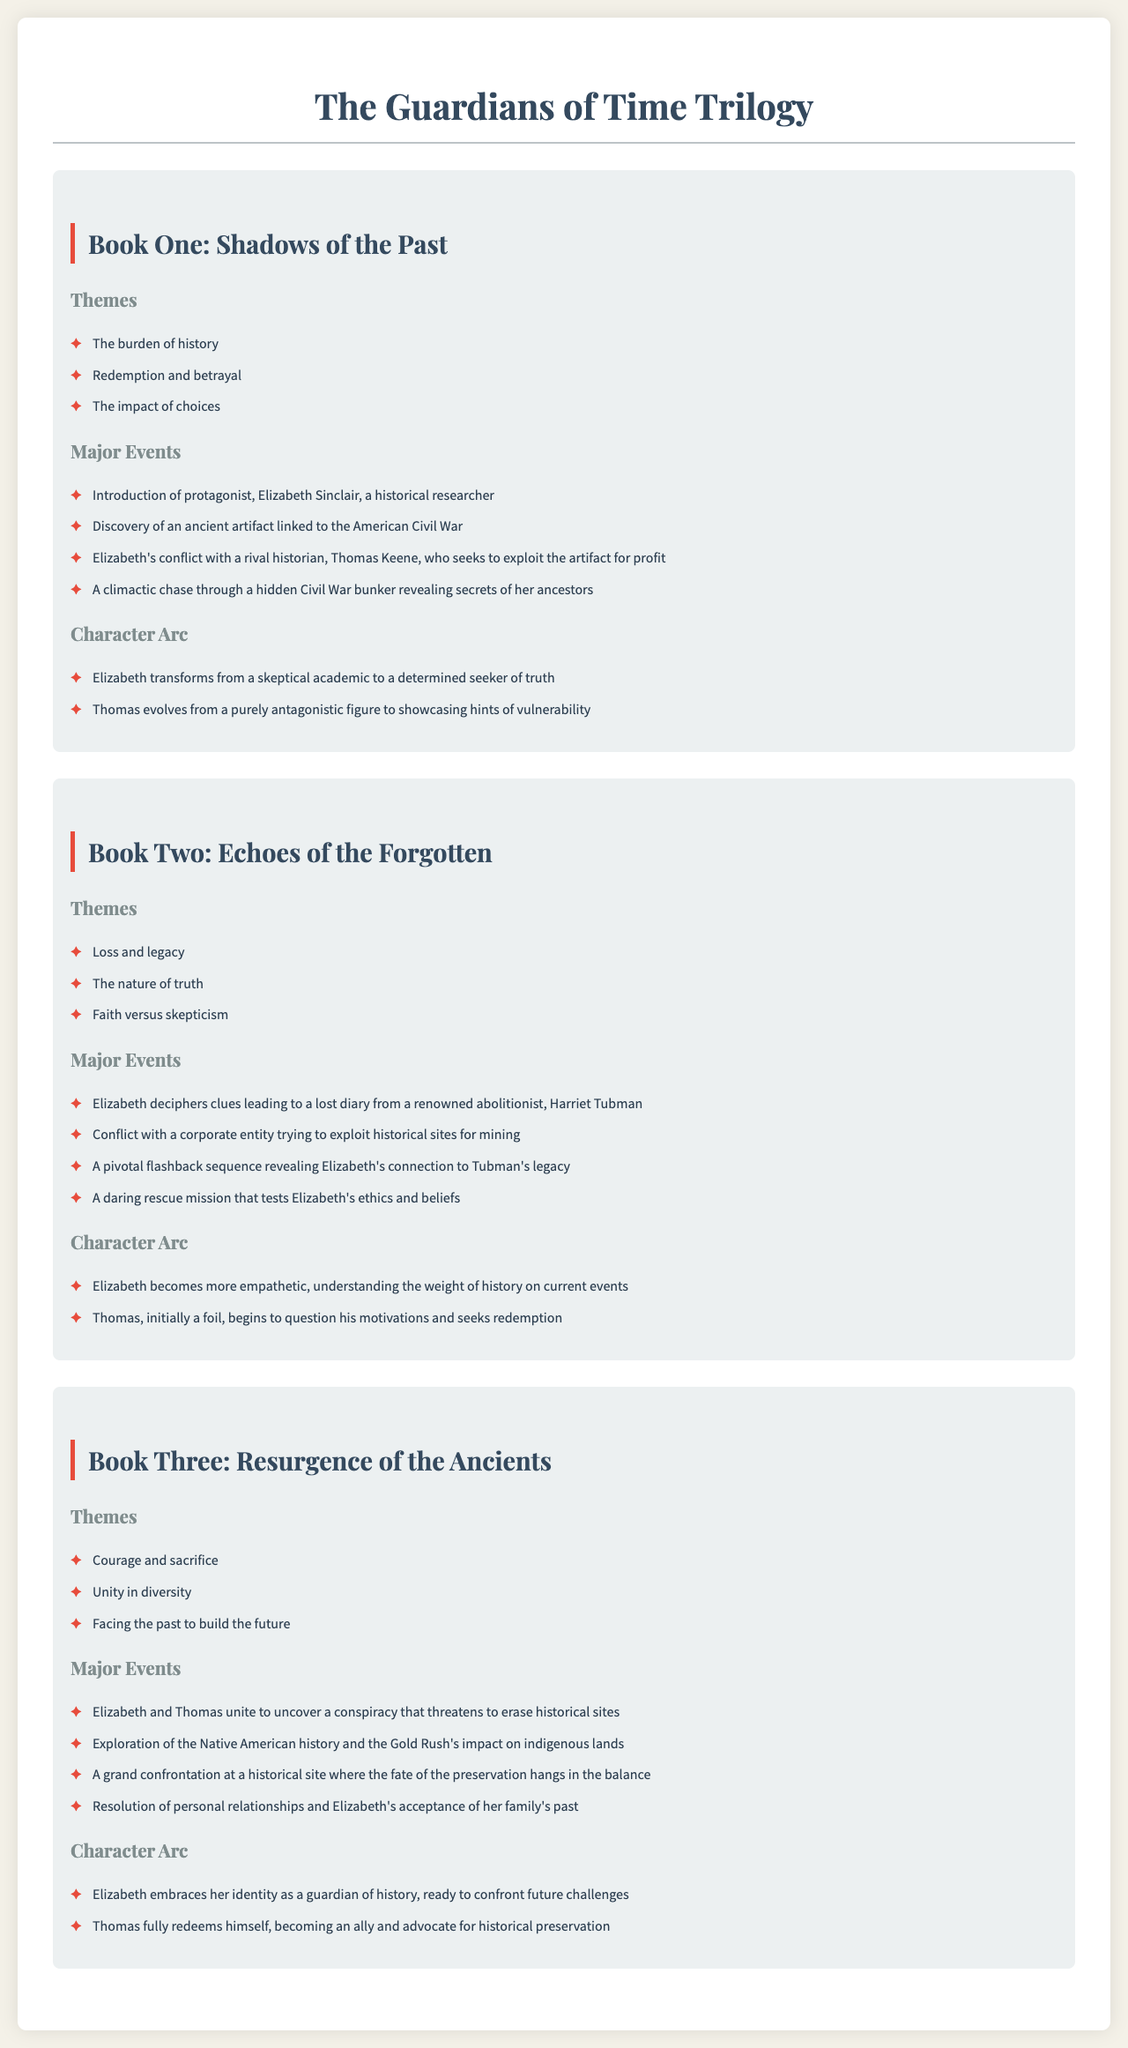what is the title of the trilogy? The title of the trilogy is presented at the top of the document.
Answer: The Guardians of Time Trilogy who is the protagonist in Book One? The protagonist of Book One is mentioned in the major events section.
Answer: Elizabeth Sinclair name a theme from Book Two. The themes listed for Book Two are highlighted in the themes section.
Answer: Loss and legacy how many major events are listed for Book Three? The major events for Book Three are found in its respective section, and the events are counted.
Answer: Four what is the character arc transformation of Elizabeth in Book One? The character arc is outlined in the respective section, showing Elizabeth's change.
Answer: From a skeptical academic to a determined seeker of truth which historical figure's diary does Elizabeth seek in Book Two? The diary she seeks is mentioned in the major events for Book Two.
Answer: Harriet Tubman describe the nature of the relationship progression of Thomas in the trilogy. The character arcs detail how Thomas's character evolves over the series.
Answer: From antagonistic to an ally what key concept is introduced in the themes of Book Three? Key concepts are highlighted in the themes section for Book Three.
Answer: Courage and sacrifice how does Elizabeth’s character evolve by the end of Book Three? This evolution is specified in her character arc description.
Answer: Embraces her identity as a guardian of history 